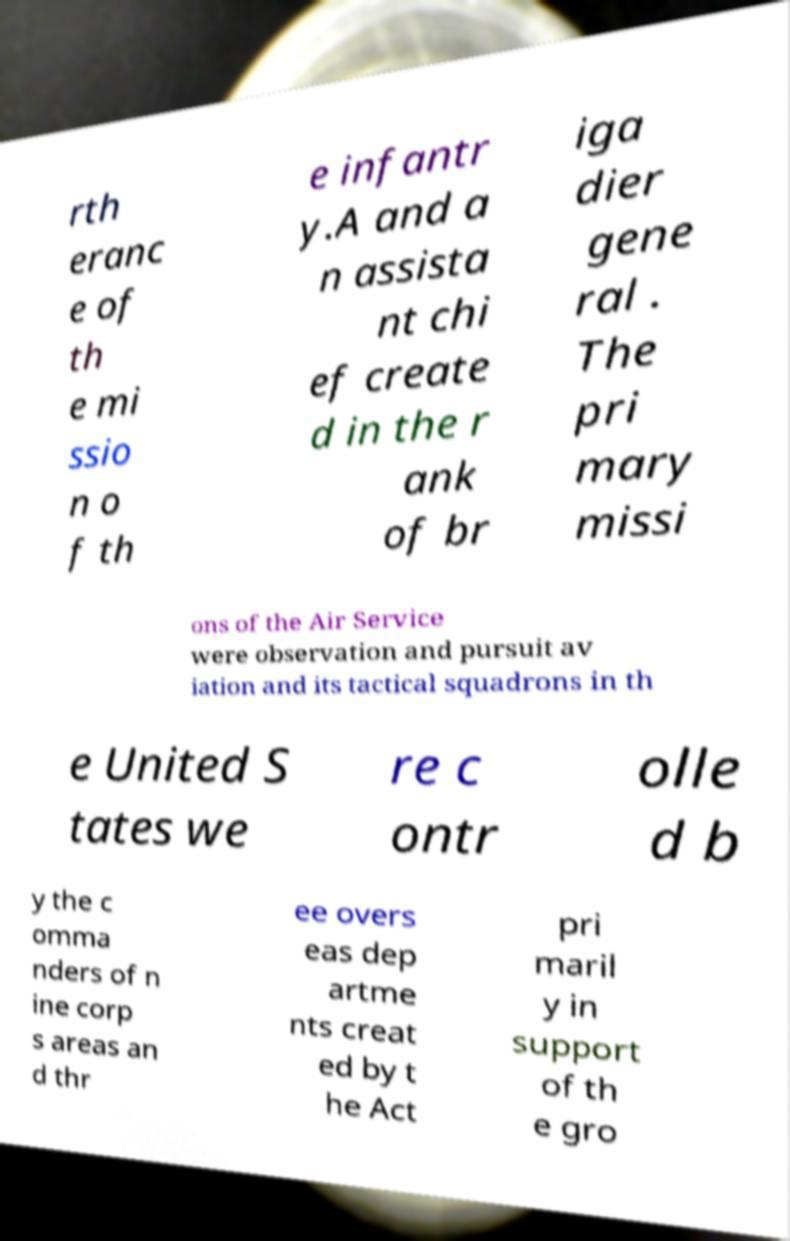There's text embedded in this image that I need extracted. Can you transcribe it verbatim? rth eranc e of th e mi ssio n o f th e infantr y.A and a n assista nt chi ef create d in the r ank of br iga dier gene ral . The pri mary missi ons of the Air Service were observation and pursuit av iation and its tactical squadrons in th e United S tates we re c ontr olle d b y the c omma nders of n ine corp s areas an d thr ee overs eas dep artme nts creat ed by t he Act pri maril y in support of th e gro 